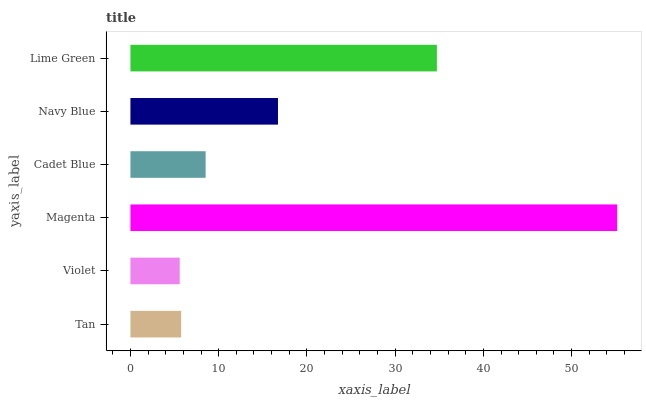Is Violet the minimum?
Answer yes or no. Yes. Is Magenta the maximum?
Answer yes or no. Yes. Is Magenta the minimum?
Answer yes or no. No. Is Violet the maximum?
Answer yes or no. No. Is Magenta greater than Violet?
Answer yes or no. Yes. Is Violet less than Magenta?
Answer yes or no. Yes. Is Violet greater than Magenta?
Answer yes or no. No. Is Magenta less than Violet?
Answer yes or no. No. Is Navy Blue the high median?
Answer yes or no. Yes. Is Cadet Blue the low median?
Answer yes or no. Yes. Is Cadet Blue the high median?
Answer yes or no. No. Is Magenta the low median?
Answer yes or no. No. 